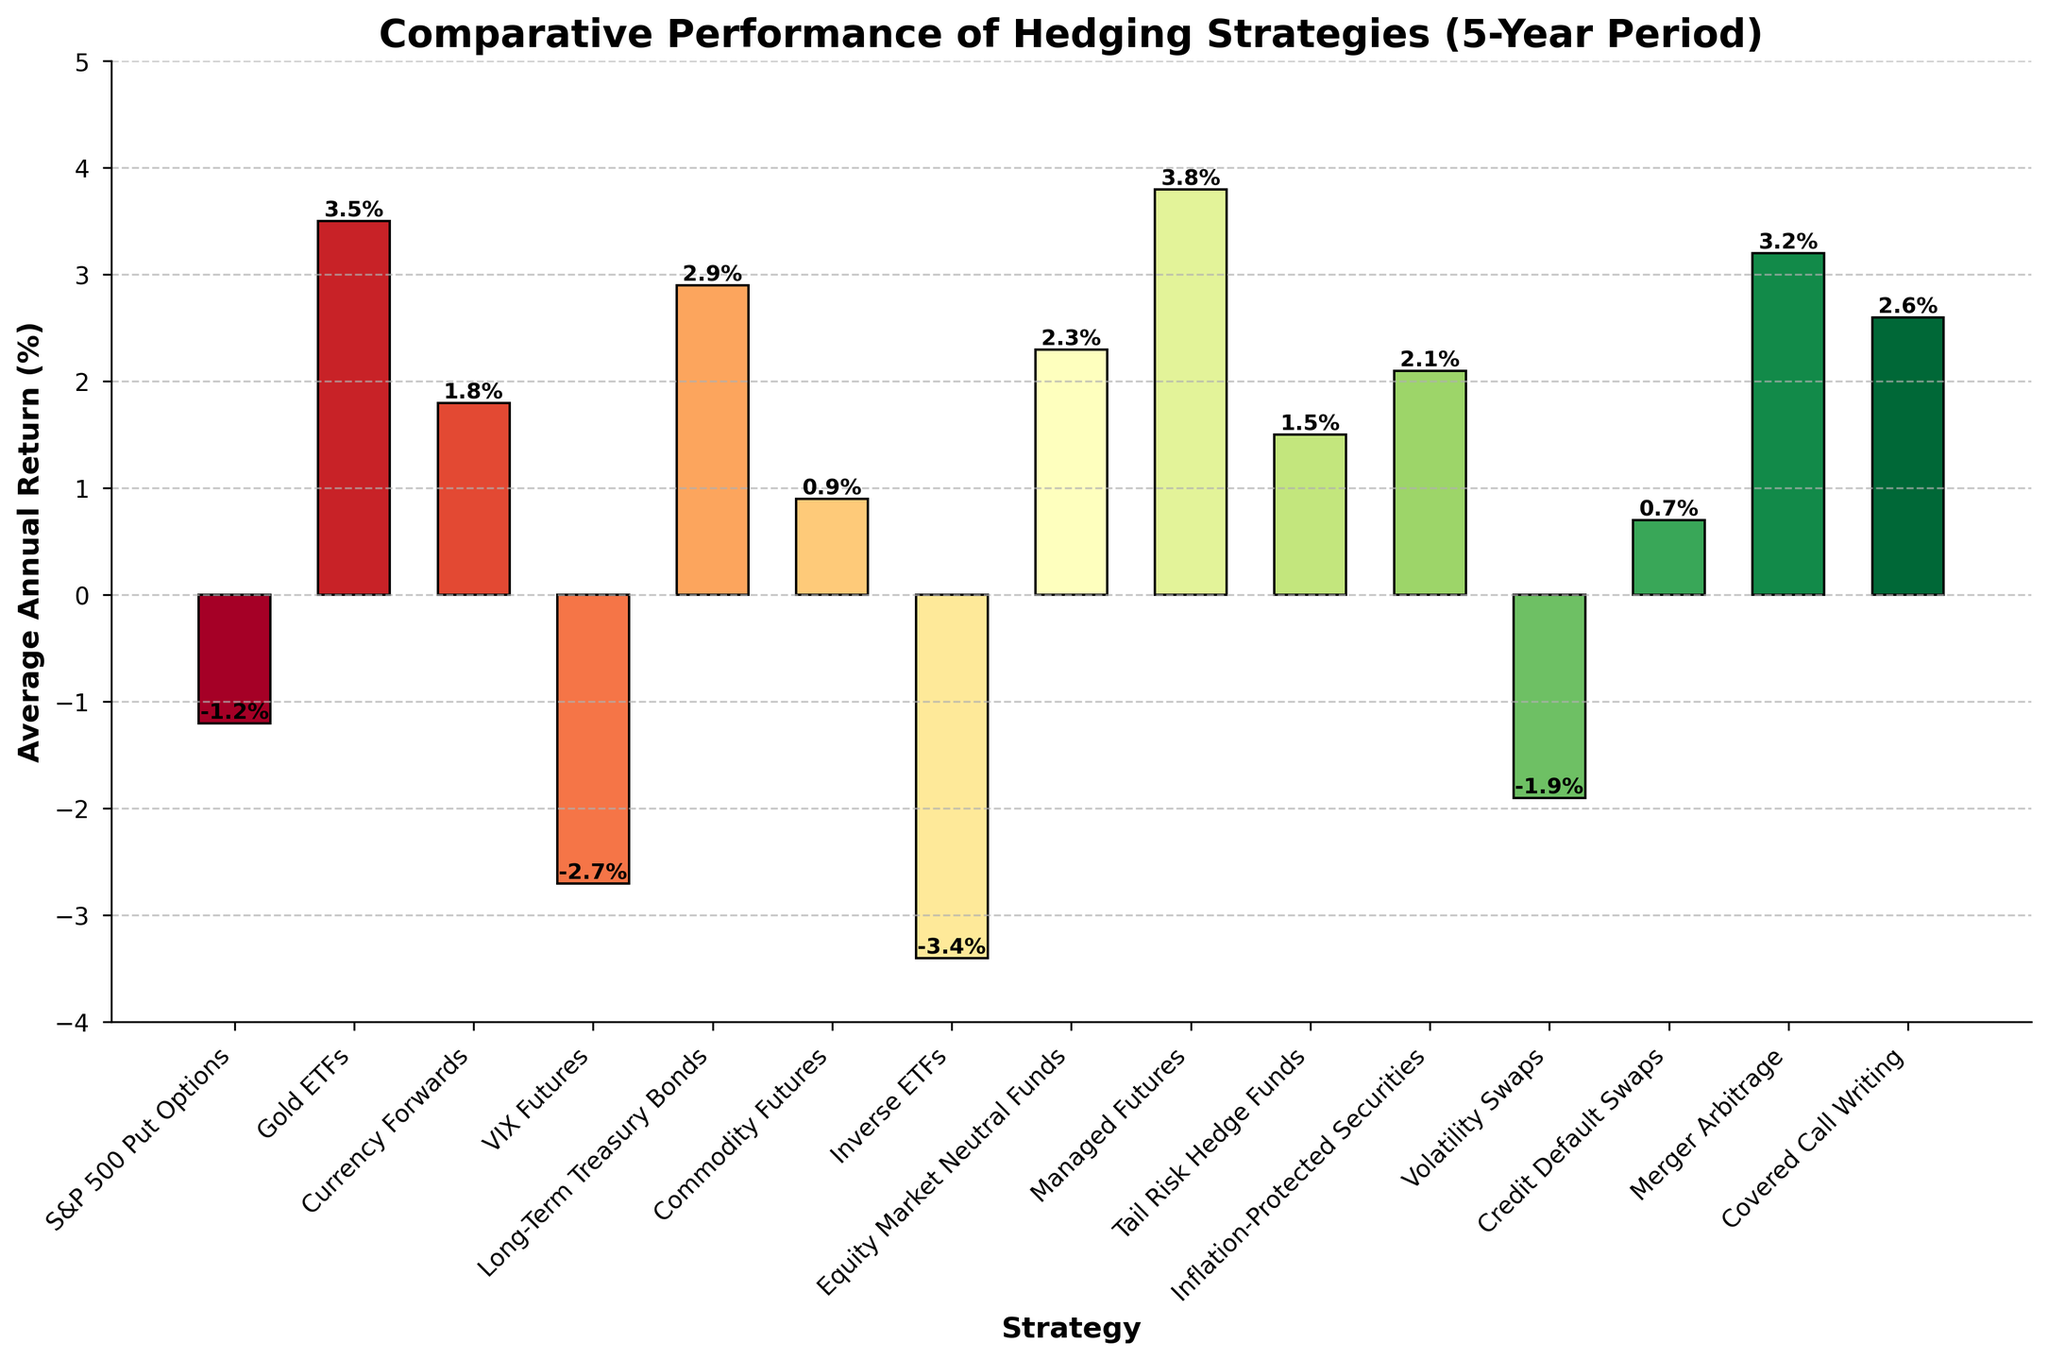which strategy has the highest average annual return? The strategy with the tallest bar represents the highest average annual return. In the chart, Managed Futures have the tallest bar.
Answer: Managed Futures which strategies have negative average annual returns? The bars that extend below the x-axis represent negative returns. These strategies are: S&P 500 Put Options, VIX Futures, Inverse ETFs, and Volatility Swaps.
Answer: S&P 500 Put Options, VIX Futures, Inverse ETFs, Volatility Swaps how much higher is the average return of Gold ETFs compared to Credit Default Swaps? Subtract the average annual return of Credit Default Swaps from that of Gold ETFs: 3.5% - 0.7% = 2.8%.
Answer: 2.8% which strategy has the lowest average annual return and what is it? The strategy with the shortest bar below the x-axis has the lowest return. Inverse ETFs have the lowest return at -3.4%.
Answer: Inverse ETFs, -3.4% what is the difference in average annual return between Merger Arbitrage and Equity Market Neutral Funds? Subtract the average annual return of Equity Market Neutral Funds from Merger Arbitrage: 3.2% - 2.3% = 0.9%.
Answer: 0.9% which strategies yield returns greater than 3%? Identify bars exceeding the 3% mark on the y-axis. These strategies are Gold ETFs, Managed Futures, and Merger Arbitrage.
Answer: Gold ETFs, Managed Futures, Merger Arbitrage do Long-Term Treasury Bonds or Equity Market Neutral Funds have a higher average annual return? Compare the heights of the bars for Long-Term Treasury Bonds and Equity Market Neutral Funds. Long-Term Treasury Bonds have a return of 2.9%, which is higher than Equity Market Neutral Funds' 2.3%.
Answer: Long-Term Treasury Bonds what is the combined average annual return of Commodity Futures and Covered Call Writing? Add the returns of Commodity Futures and Covered Call Writing: 0.9% + 2.6% = 3.5%.
Answer: 3.5% which strategies have an average annual return within the range of 1% to 2%? Identify bars within the range of 1% to 2% on the y-axis. These strategies include: Currency Forwards, Tail Risk Hedge Funds, and Inflation-Protected Securities.
Answer: Currency Forwards, Tail Risk Hedge Funds, Inflation-Protected Securities is the average annual return of Volatility Swaps higher than that of VIX Futures? Compare the heights of the bars for Volatility Swaps and VIX Futures. Volatility Swaps have a return of -1.9%, while VIX Futures have -2.7%. Therefore, Volatility Swaps are higher.
Answer: Yes 